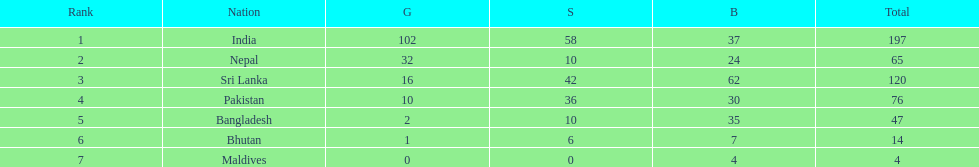Name a country listed in the table, other than india? Nepal. 